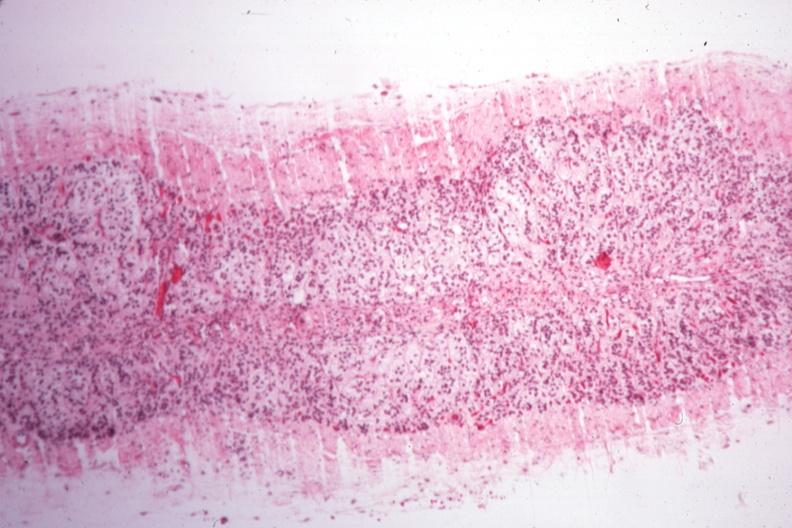s capillary present?
Answer the question using a single word or phrase. No 